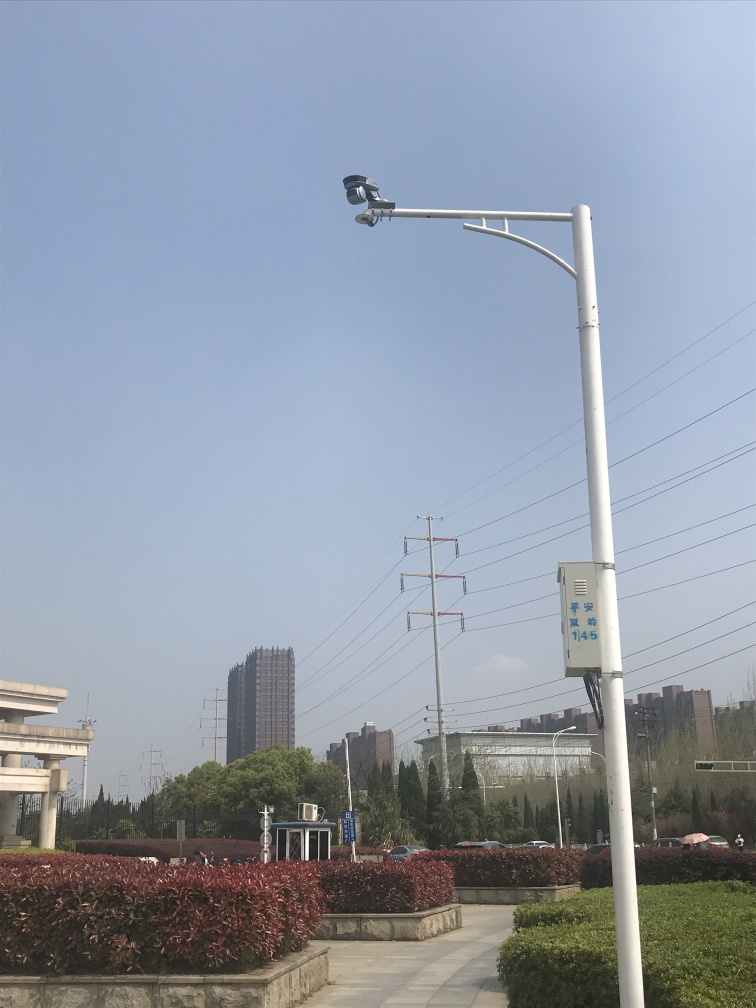Can you describe what's happening in this image? The image depicts an urban scene on a sunny day. In the foreground, there's a tall lamp post equipped with a security camera. The background features a mix of vegetation, power lines, and modern buildings, implying the setting could be a city park area or a similar public space.  What time of day does it seem to be? Considering the clear sky and the quality of the light, it appears to be midday when the sun is at its peak, which is also suggested by the minimal shadow cast by the lamp post. 